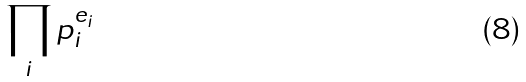Convert formula to latex. <formula><loc_0><loc_0><loc_500><loc_500>\prod _ { i } p _ { i } ^ { e _ { i } }</formula> 